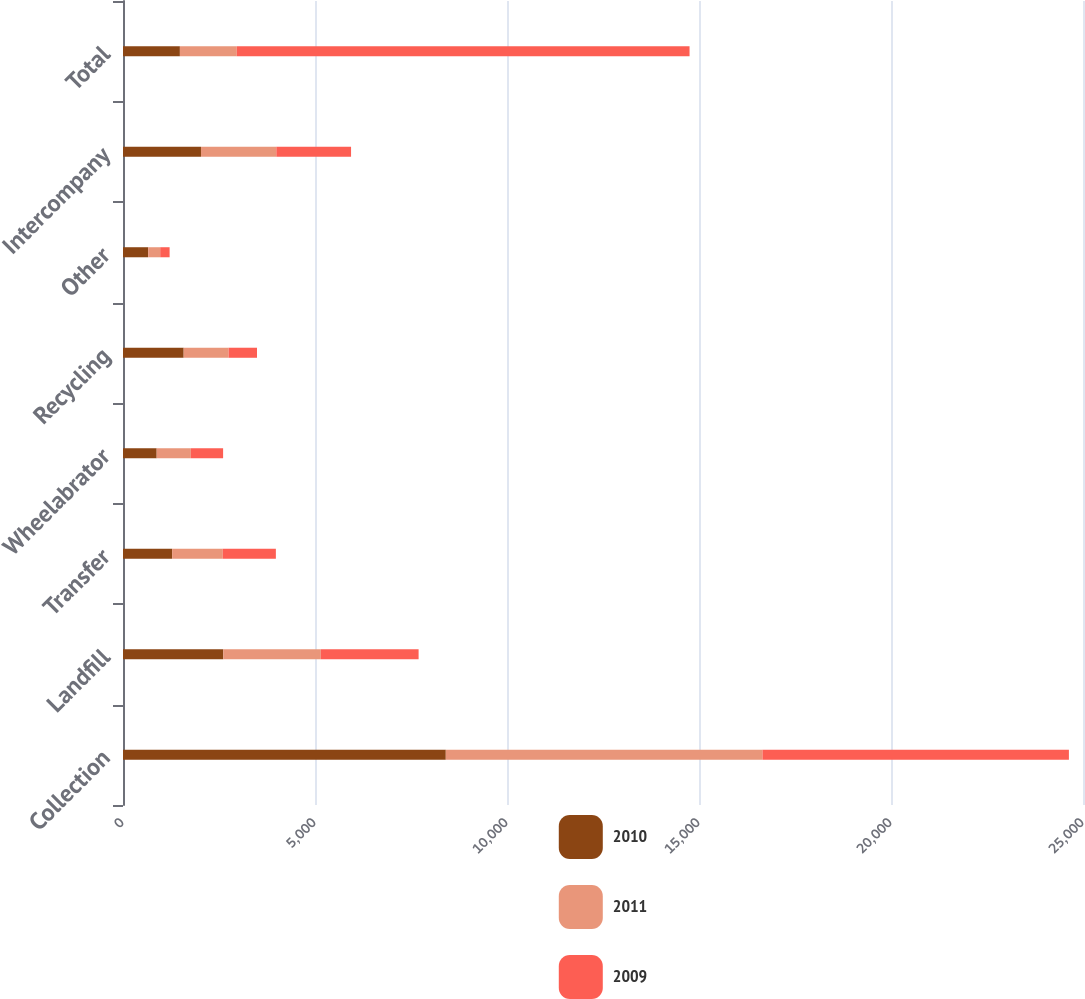<chart> <loc_0><loc_0><loc_500><loc_500><stacked_bar_chart><ecel><fcel>Collection<fcel>Landfill<fcel>Transfer<fcel>Wheelabrator<fcel>Recycling<fcel>Other<fcel>Intercompany<fcel>Total<nl><fcel>2010<fcel>8406<fcel>2611<fcel>1280<fcel>877<fcel>1580<fcel>655<fcel>2031<fcel>1481.5<nl><fcel>2011<fcel>8247<fcel>2540<fcel>1318<fcel>889<fcel>1169<fcel>314<fcel>1962<fcel>1481.5<nl><fcel>2009<fcel>7980<fcel>2547<fcel>1383<fcel>841<fcel>741<fcel>245<fcel>1946<fcel>11791<nl></chart> 